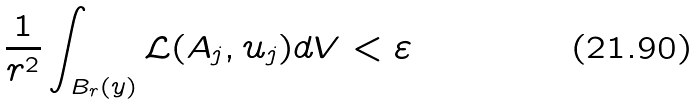<formula> <loc_0><loc_0><loc_500><loc_500>\frac { 1 } { r ^ { 2 } } \int _ { B _ { r } ( y ) } \mathcal { L } ( A _ { j } , u _ { j } ) d V < \varepsilon</formula> 